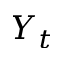Convert formula to latex. <formula><loc_0><loc_0><loc_500><loc_500>Y _ { t }</formula> 